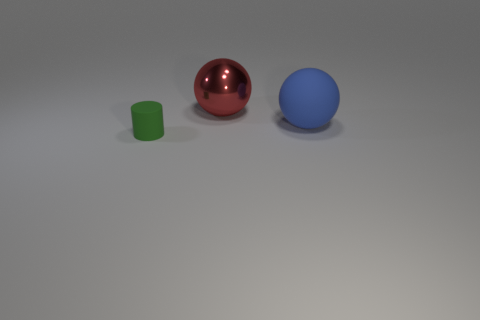How big is the ball behind the rubber object that is to the right of the tiny green rubber thing?
Make the answer very short. Large. What number of cubes are either rubber objects or big red things?
Your response must be concise. 0. Is the size of the blue ball the same as the ball behind the blue matte sphere?
Provide a short and direct response. Yes. Are there more large spheres in front of the big shiny sphere than small cubes?
Your response must be concise. Yes. What size is the blue thing that is the same material as the tiny green object?
Provide a succinct answer. Large. Is there another sphere of the same color as the rubber sphere?
Your answer should be very brief. No. What number of objects are big brown balls or things that are behind the large blue object?
Provide a succinct answer. 1. Are there more cylinders than small yellow rubber cylinders?
Give a very brief answer. Yes. Are there any green objects that have the same material as the blue object?
Provide a short and direct response. Yes. What shape is the object that is left of the big blue rubber thing and in front of the large red metallic ball?
Provide a succinct answer. Cylinder. 